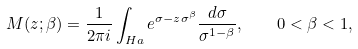Convert formula to latex. <formula><loc_0><loc_0><loc_500><loc_500>M ( z ; \beta ) = \frac { 1 } { 2 \pi i } \int _ { H a } e ^ { \sigma - z \sigma ^ { \beta } } \frac { d \sigma } { \sigma ^ { 1 - \beta } } , \quad 0 < \beta < 1 ,</formula> 